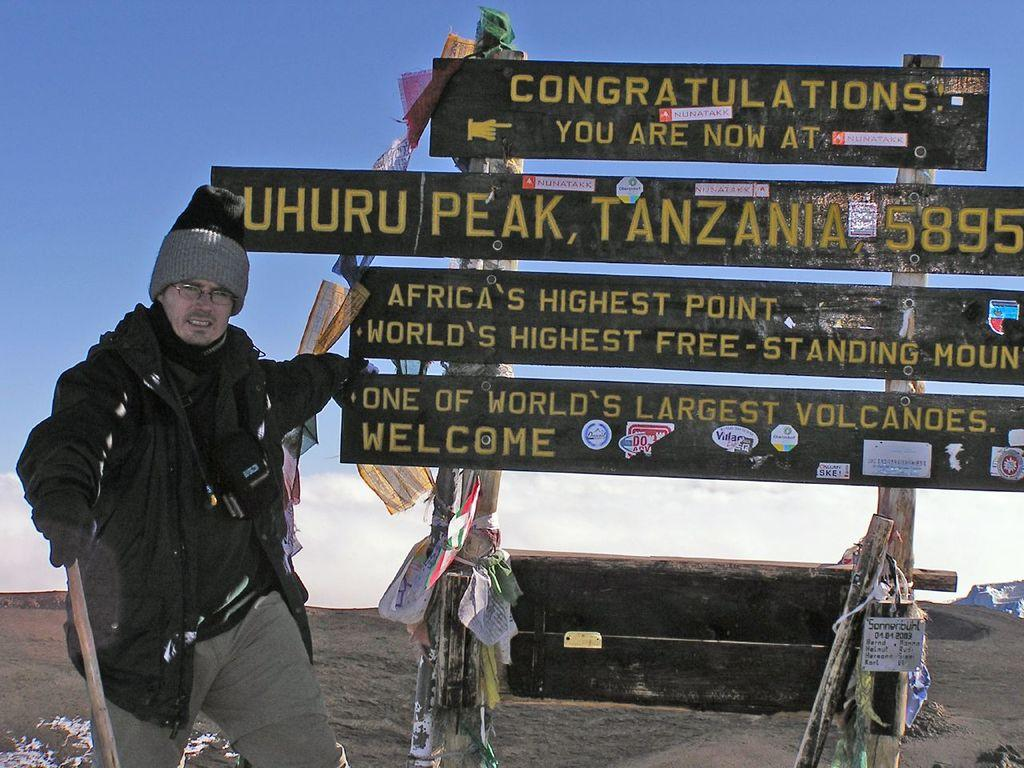Who or what is the main subject in the image? There is a person in the image. What can be observed about the person's attire? The person is wearing clothes. What object is the person holding in the image? The person is holding a stick with his hand. What is located in the middle of the image? There is a board in the middle of the image. What is visible at the top of the image? The sky is visible at the top of the image. What type of discovery was made in the park by the spy in the image? There is no mention of a park, discovery, or spy in the image. The image features a person holding a stick and standing near a board, with the sky visible at the top. 